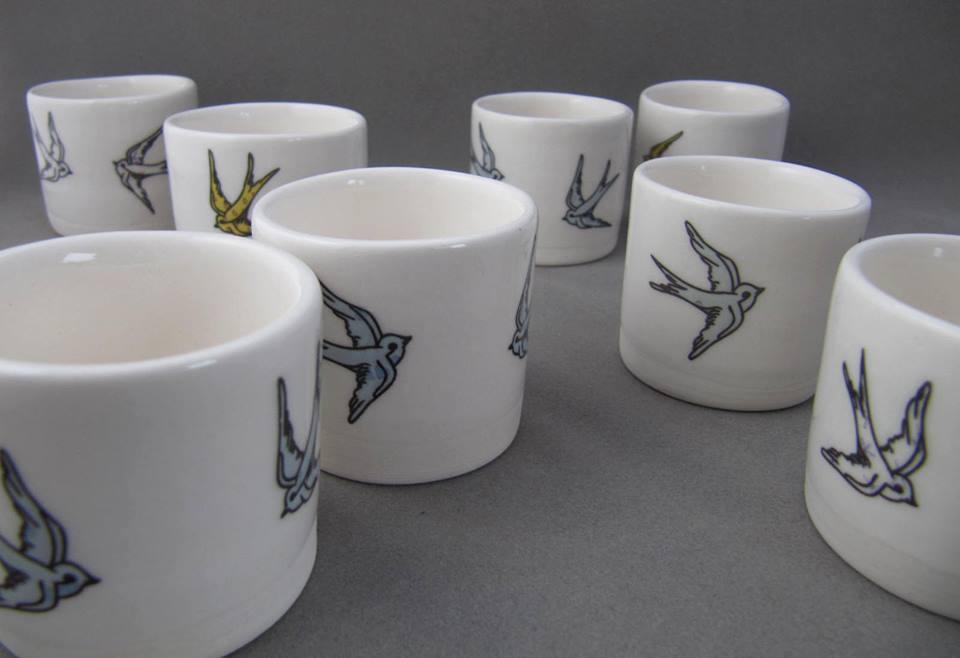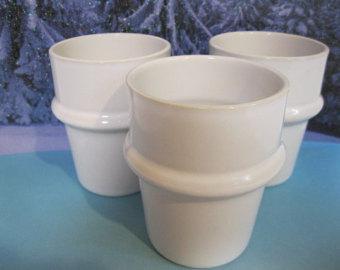The first image is the image on the left, the second image is the image on the right. Given the left and right images, does the statement "There are 3 white coffee cups and saucers" hold true? Answer yes or no. No. The first image is the image on the left, the second image is the image on the right. Evaluate the accuracy of this statement regarding the images: "The right image has three empty white coffee cups.". Is it true? Answer yes or no. Yes. 